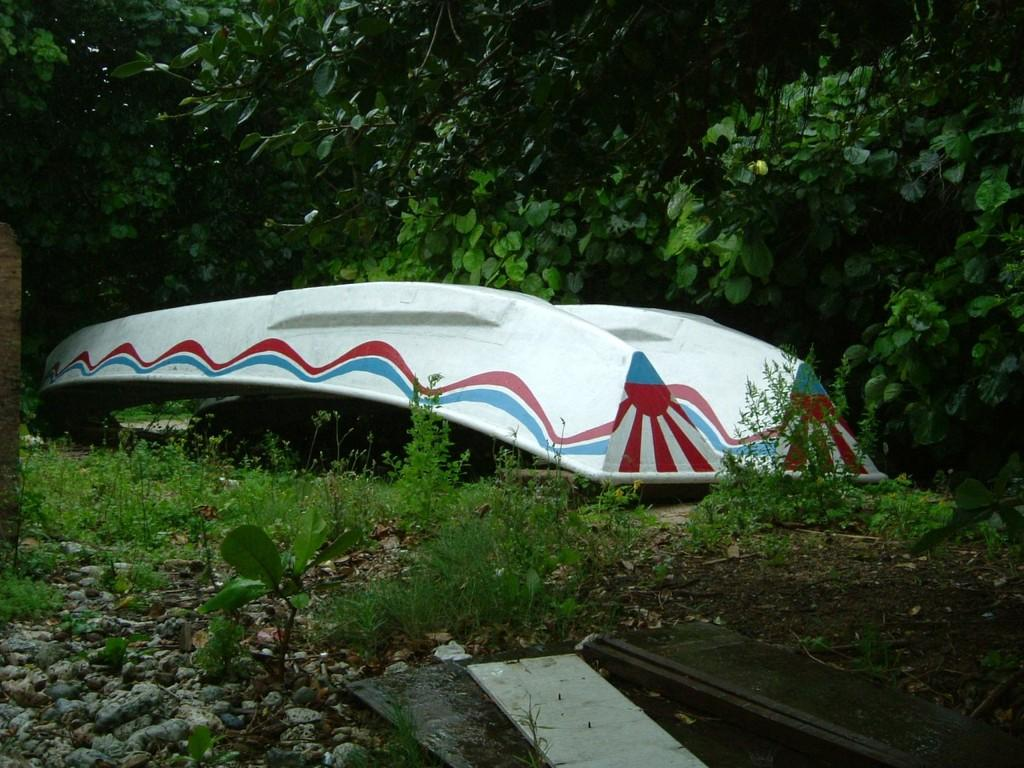What is the main subject of the image? There is a boat in the image. What else can be seen in the image besides the boat? There are plants, stones, and objects on the ground visible in the image. What is the background of the image? There are trees in the background of the image. What type of plantation can be seen in the image? There is no plantation present in the image; it features a boat, plants, stones, objects on the ground, and trees in the background. Can you tell me how many cribs are visible in the image? There are no cribs present in the image. 